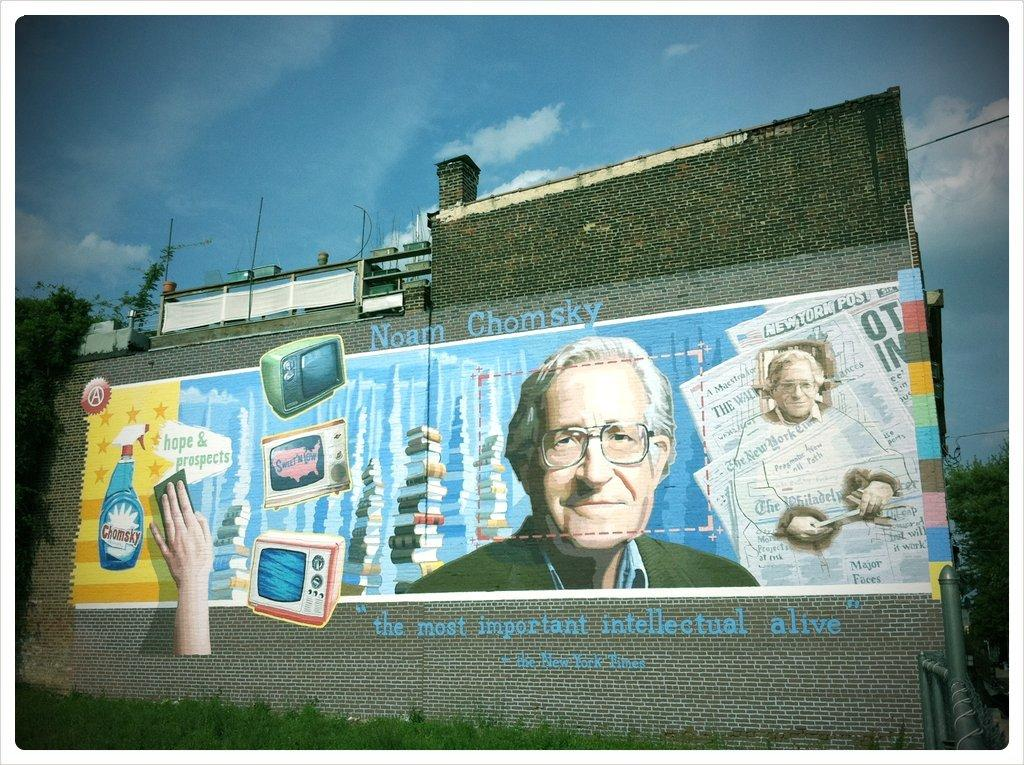<image>
Describe the image concisely. Drawing on a wall showing a man's face and the name "Noam Chomsky" on top. 